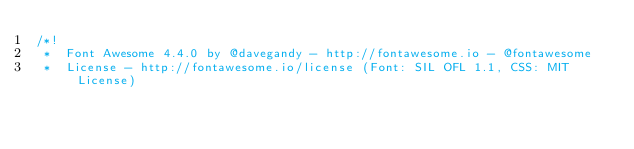Convert code to text. <code><loc_0><loc_0><loc_500><loc_500><_CSS_>/*!
 *  Font Awesome 4.4.0 by @davegandy - http://fontawesome.io - @fontawesome
 *  License - http://fontawesome.io/license (Font: SIL OFL 1.1, CSS: MIT License)</code> 